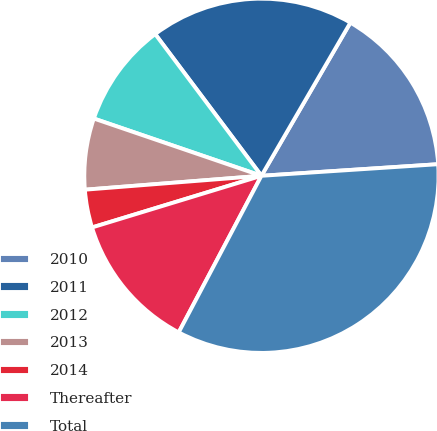<chart> <loc_0><loc_0><loc_500><loc_500><pie_chart><fcel>2010<fcel>2011<fcel>2012<fcel>2013<fcel>2014<fcel>Thereafter<fcel>Total<nl><fcel>15.58%<fcel>18.61%<fcel>9.52%<fcel>6.49%<fcel>3.46%<fcel>12.55%<fcel>33.77%<nl></chart> 